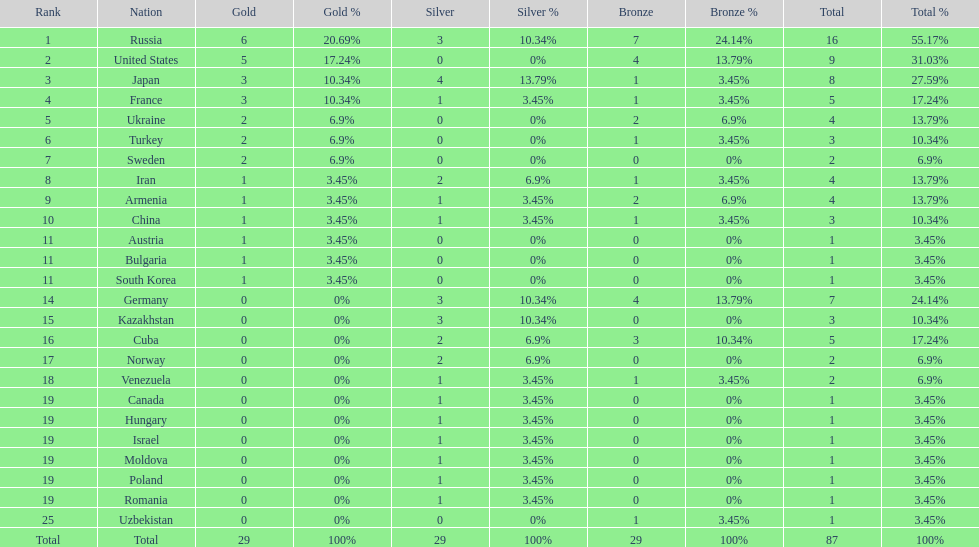Which country had the highest number of medals? Russia. 